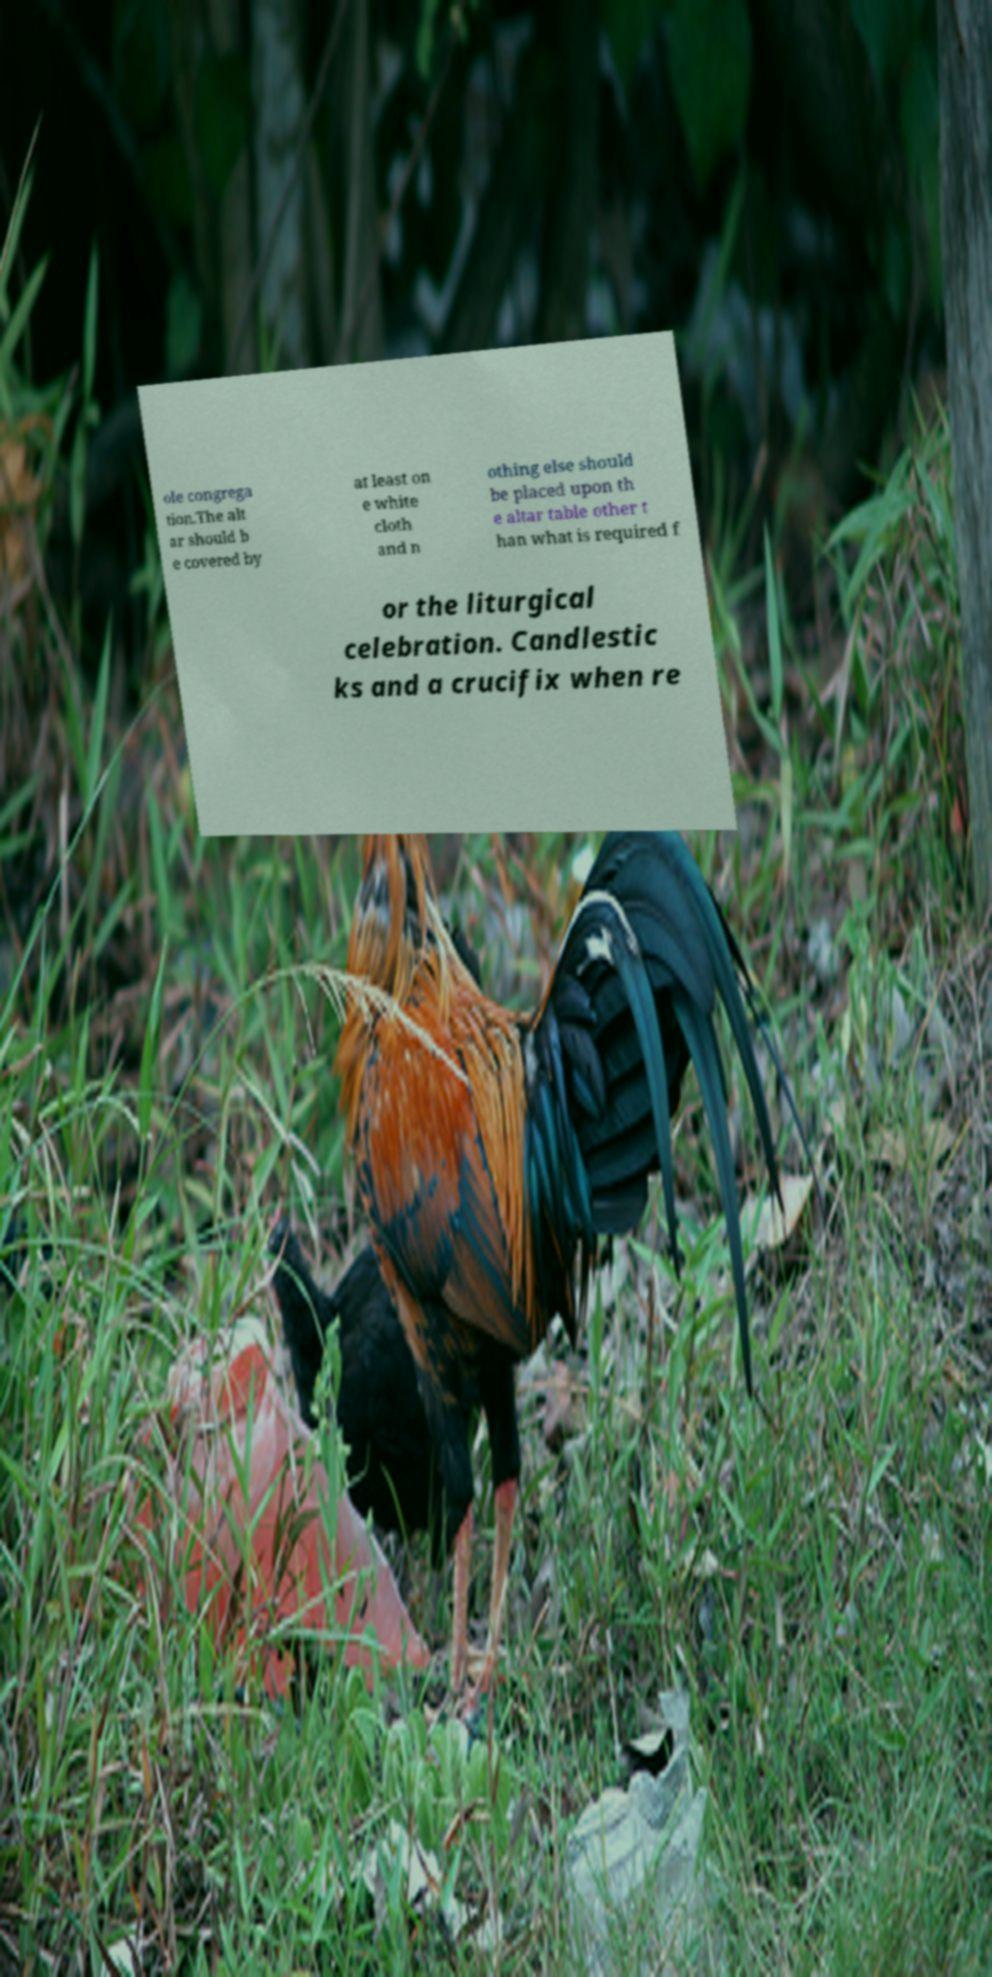Can you accurately transcribe the text from the provided image for me? ole congrega tion.The alt ar should b e covered by at least on e white cloth and n othing else should be placed upon th e altar table other t han what is required f or the liturgical celebration. Candlestic ks and a crucifix when re 